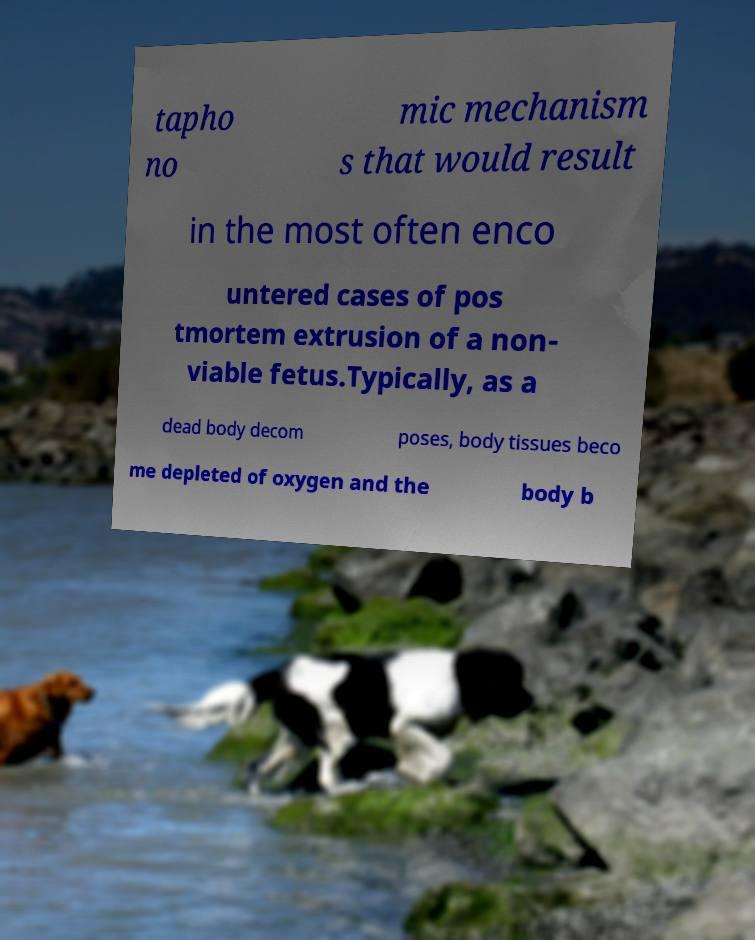Can you accurately transcribe the text from the provided image for me? tapho no mic mechanism s that would result in the most often enco untered cases of pos tmortem extrusion of a non- viable fetus.Typically, as a dead body decom poses, body tissues beco me depleted of oxygen and the body b 